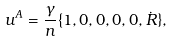<formula> <loc_0><loc_0><loc_500><loc_500>u ^ { A } = \frac { \gamma } { n } \{ 1 , 0 , 0 , 0 , 0 , \dot { R } \} ,</formula> 